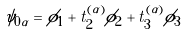<formula> <loc_0><loc_0><loc_500><loc_500>\psi _ { 0 \alpha } = \phi _ { 1 } + t _ { 2 } ^ { ( \alpha ) } \phi _ { 2 } + t _ { 3 } ^ { ( \alpha ) } \phi _ { 3 }</formula> 